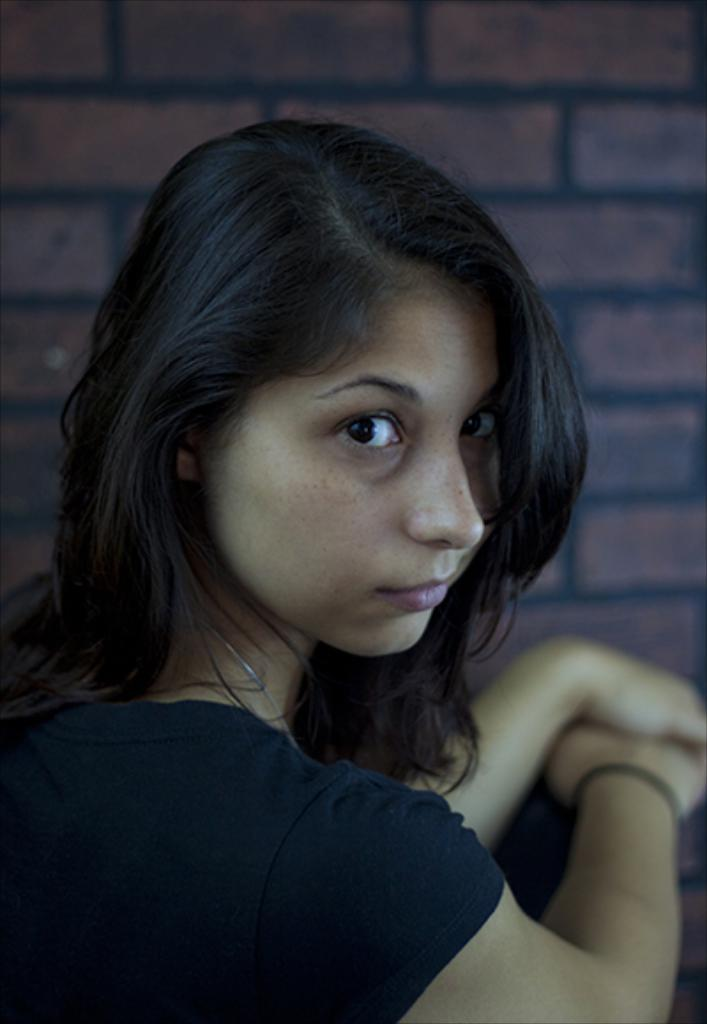What is the main subject of the image? There is a person in the image. Can you describe the position of the person in the image? The person is in front of the image. What is visible behind the person in the image? There is a wall visible behind the person. What type of apples can be seen growing on the person's legs in the image? There are no apples or legs visible on the person in the image. What scent can be detected coming from the person in the image? There is no information about the scent in the image. 